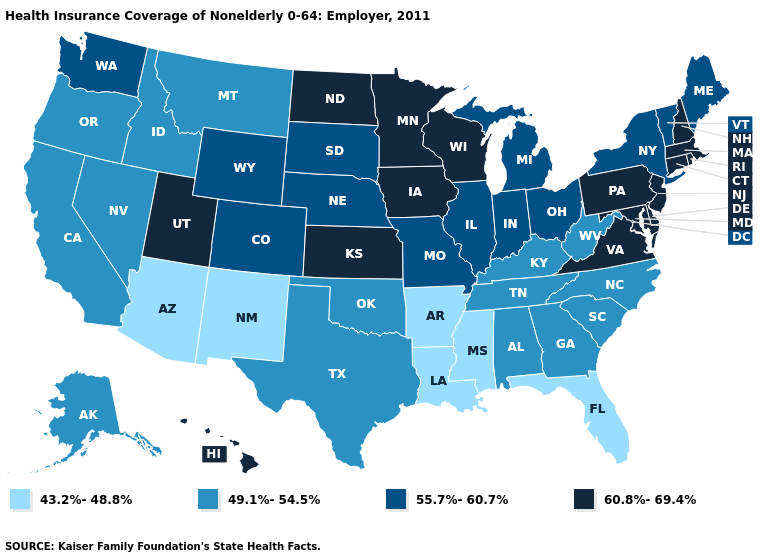What is the highest value in the USA?
Be succinct. 60.8%-69.4%. Which states have the highest value in the USA?
Keep it brief. Connecticut, Delaware, Hawaii, Iowa, Kansas, Maryland, Massachusetts, Minnesota, New Hampshire, New Jersey, North Dakota, Pennsylvania, Rhode Island, Utah, Virginia, Wisconsin. What is the value of Montana?
Be succinct. 49.1%-54.5%. Does Michigan have the lowest value in the USA?
Short answer required. No. What is the value of Connecticut?
Be succinct. 60.8%-69.4%. What is the highest value in states that border Minnesota?
Concise answer only. 60.8%-69.4%. What is the value of Michigan?
Short answer required. 55.7%-60.7%. What is the lowest value in the USA?
Concise answer only. 43.2%-48.8%. What is the highest value in the West ?
Quick response, please. 60.8%-69.4%. Does Connecticut have the highest value in the Northeast?
Short answer required. Yes. What is the lowest value in the South?
Answer briefly. 43.2%-48.8%. What is the value of North Carolina?
Short answer required. 49.1%-54.5%. How many symbols are there in the legend?
Keep it brief. 4. Does the first symbol in the legend represent the smallest category?
Keep it brief. Yes. 